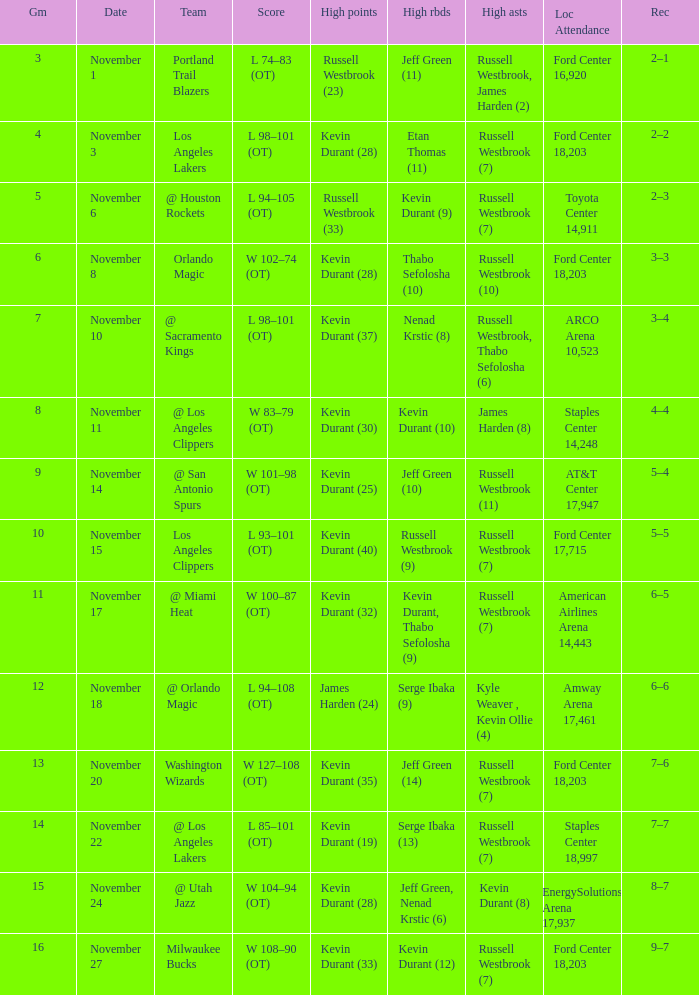What was the record in the game in which Jeff Green (14) did the most high rebounds? 7–6. 